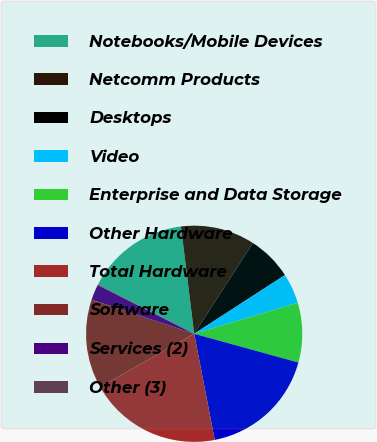Convert chart. <chart><loc_0><loc_0><loc_500><loc_500><pie_chart><fcel>Notebooks/Mobile Devices<fcel>Netcomm Products<fcel>Desktops<fcel>Video<fcel>Enterprise and Data Storage<fcel>Other Hardware<fcel>Total Hardware<fcel>Software<fcel>Services (2)<fcel>Other (3)<nl><fcel>15.48%<fcel>11.1%<fcel>6.71%<fcel>4.52%<fcel>8.9%<fcel>17.67%<fcel>19.87%<fcel>13.29%<fcel>2.33%<fcel>0.13%<nl></chart> 